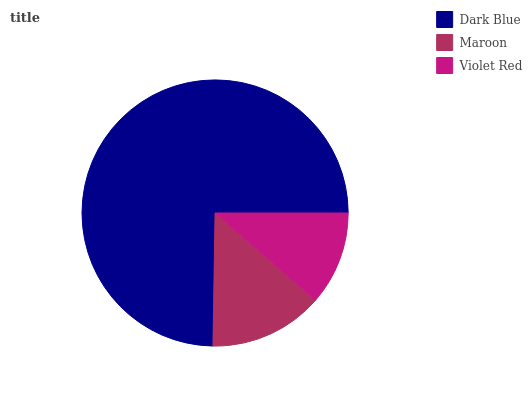Is Violet Red the minimum?
Answer yes or no. Yes. Is Dark Blue the maximum?
Answer yes or no. Yes. Is Maroon the minimum?
Answer yes or no. No. Is Maroon the maximum?
Answer yes or no. No. Is Dark Blue greater than Maroon?
Answer yes or no. Yes. Is Maroon less than Dark Blue?
Answer yes or no. Yes. Is Maroon greater than Dark Blue?
Answer yes or no. No. Is Dark Blue less than Maroon?
Answer yes or no. No. Is Maroon the high median?
Answer yes or no. Yes. Is Maroon the low median?
Answer yes or no. Yes. Is Violet Red the high median?
Answer yes or no. No. Is Violet Red the low median?
Answer yes or no. No. 